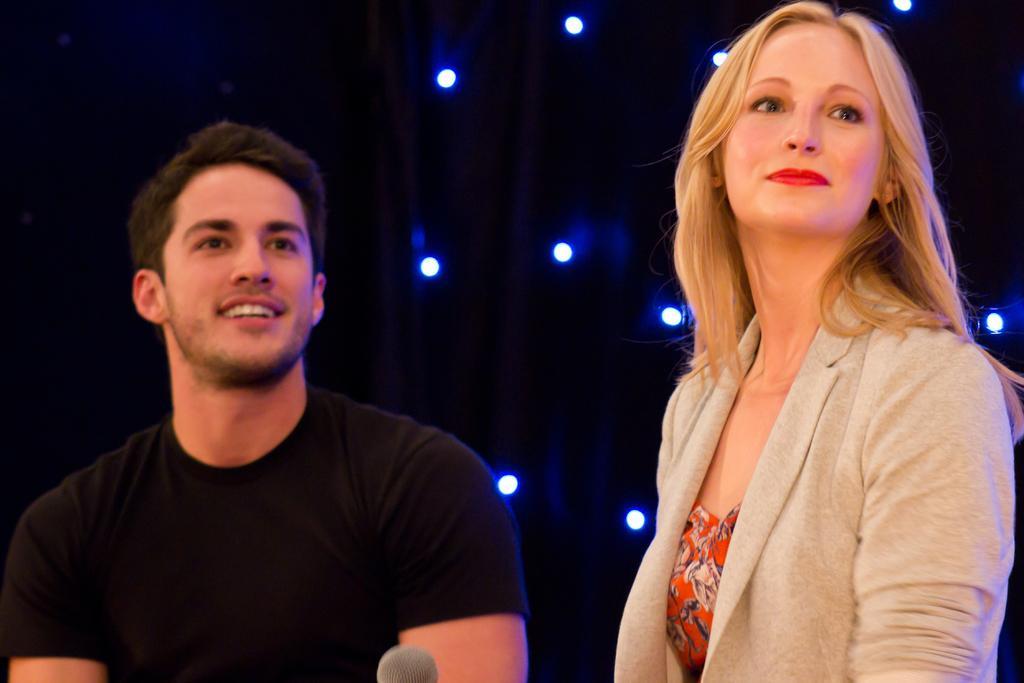Can you describe this image briefly? In this image we can see a man wearing black color T-shirt and a woman wearing orange color dress with cream color coat, in the background there are some lights. 